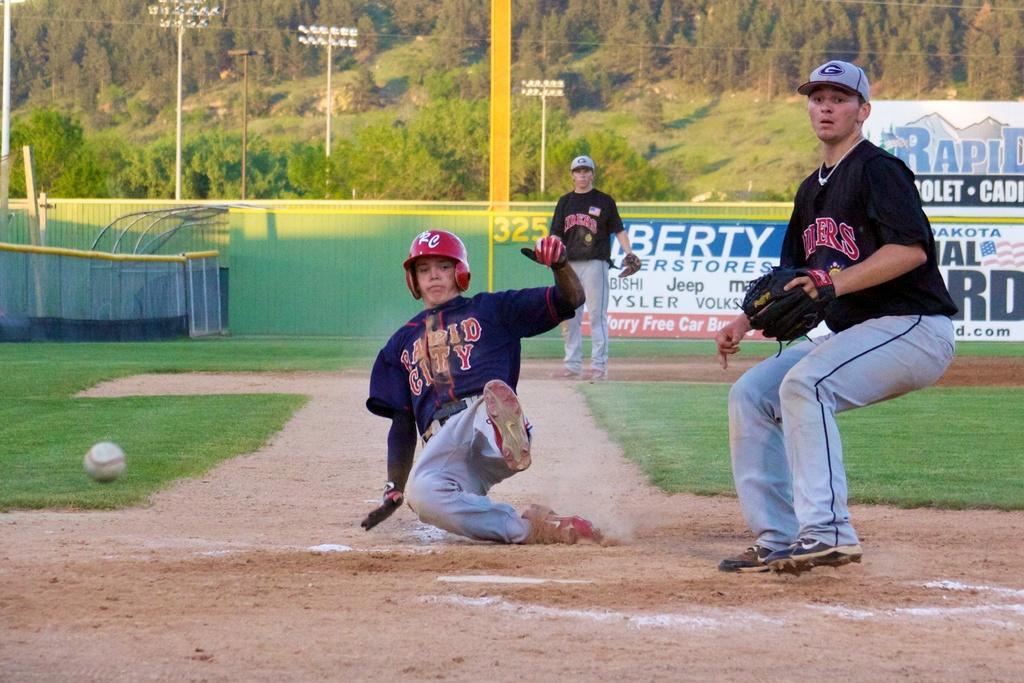Please provide a concise description of this image. In this image I can see three persons. In front I can see two people are playing game and I can also see the ball in white color. Background I can see the fencing, few boards attached to the poles. I can also see few light poles and the trees are in green color. 